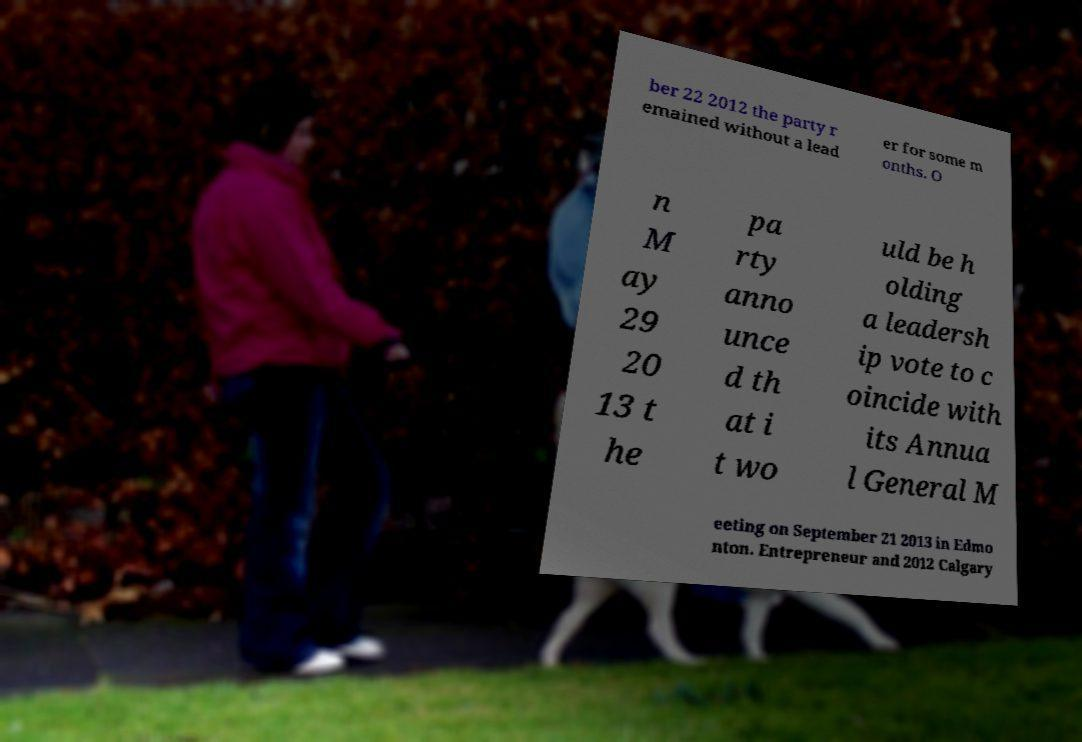What messages or text are displayed in this image? I need them in a readable, typed format. ber 22 2012 the party r emained without a lead er for some m onths. O n M ay 29 20 13 t he pa rty anno unce d th at i t wo uld be h olding a leadersh ip vote to c oincide with its Annua l General M eeting on September 21 2013 in Edmo nton. Entrepreneur and 2012 Calgary 